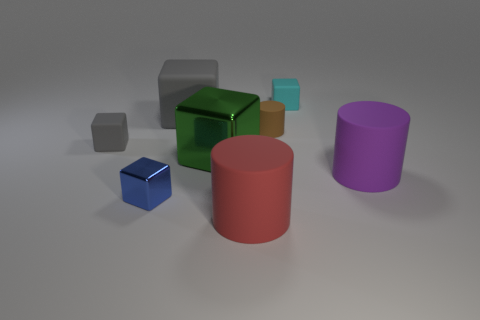Does the blue block have the same material as the large purple thing?
Provide a succinct answer. No. How many large objects are red cylinders or yellow shiny spheres?
Offer a very short reply. 1. The large block that is the same material as the purple cylinder is what color?
Provide a succinct answer. Gray. What is the color of the tiny block that is behind the tiny brown rubber object?
Your answer should be compact. Cyan. How many other rubber cubes are the same color as the large matte block?
Offer a very short reply. 1. Is the number of big gray rubber objects that are right of the big red cylinder less than the number of red rubber cylinders in front of the tiny gray cube?
Give a very brief answer. Yes. There is a tiny metallic object; how many blocks are left of it?
Keep it short and to the point. 1. Is there a object that has the same material as the purple cylinder?
Give a very brief answer. Yes. Is the number of cyan cubes that are to the right of the small blue metallic cube greater than the number of big purple matte objects that are in front of the red matte cylinder?
Keep it short and to the point. Yes. What is the size of the cyan rubber block?
Your response must be concise. Small. 